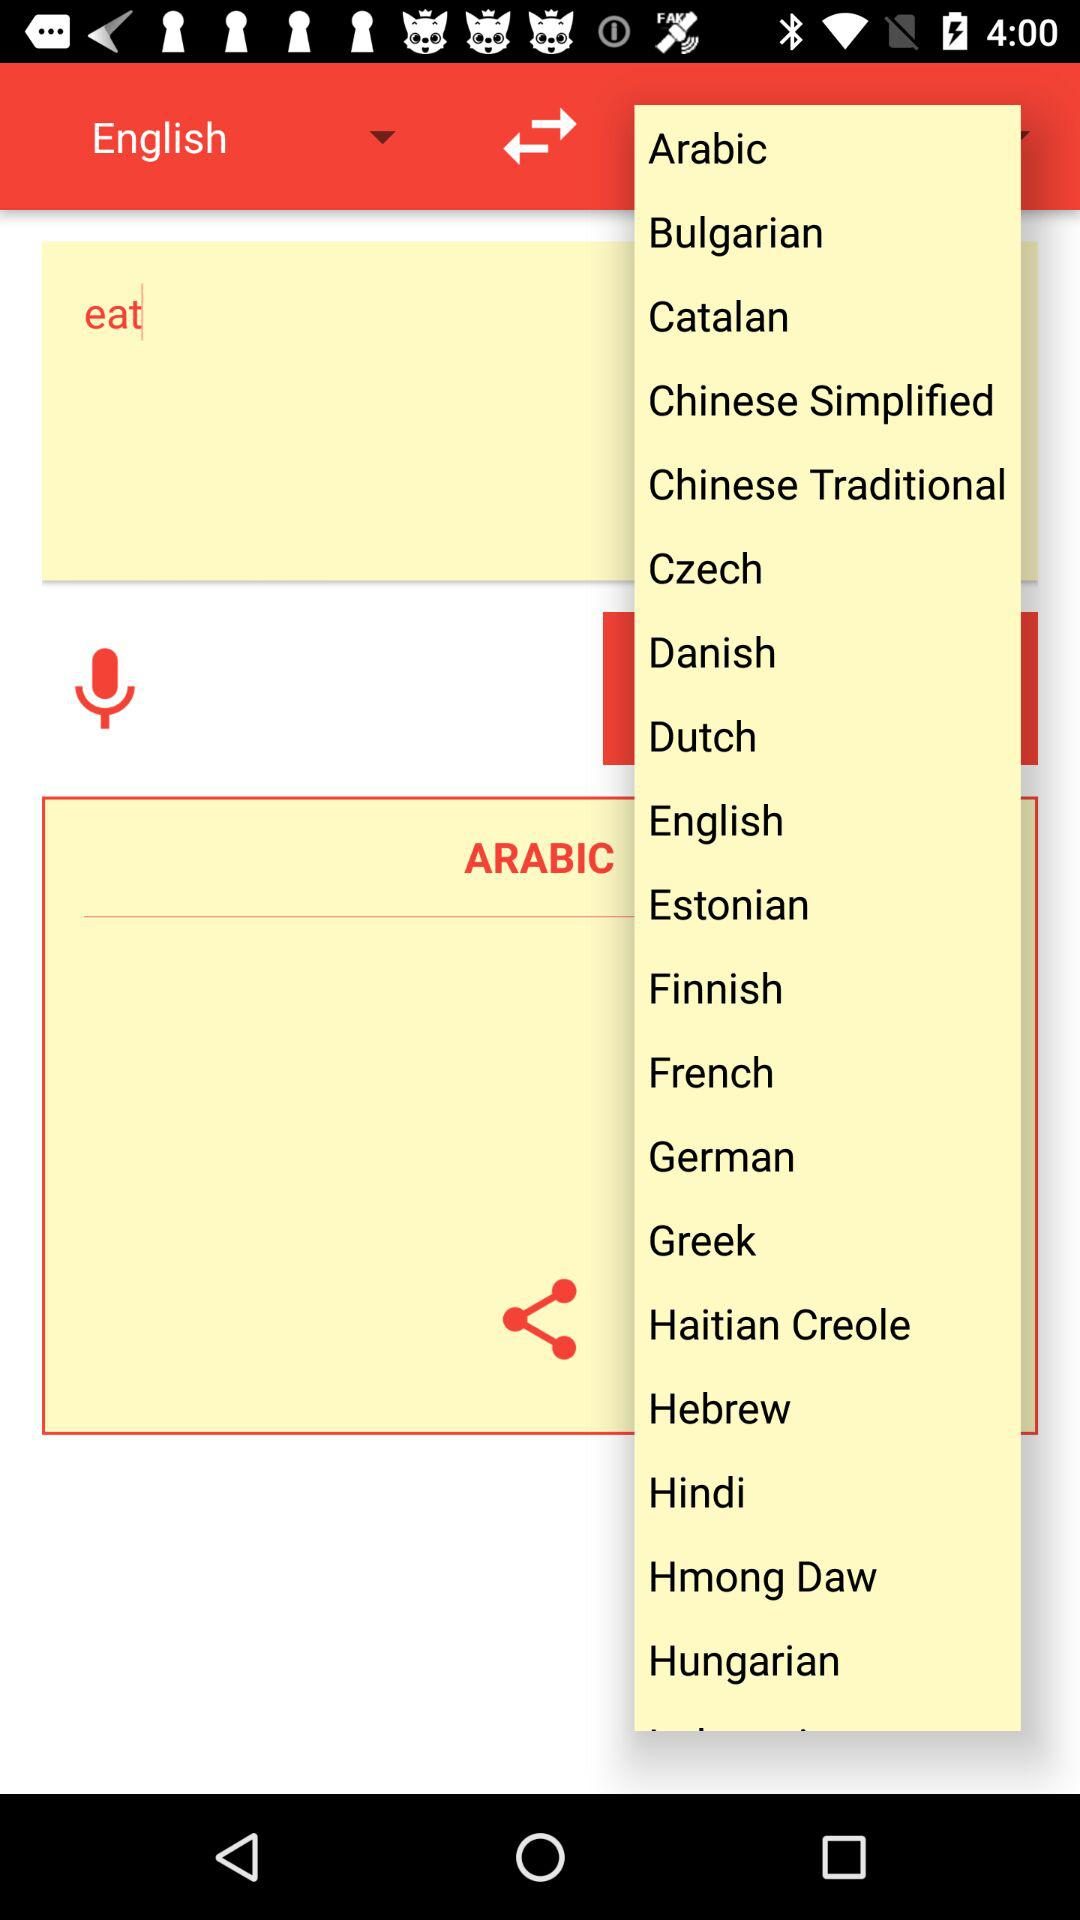How many languages are available to choose from?
Answer the question using a single word or phrase. 19 